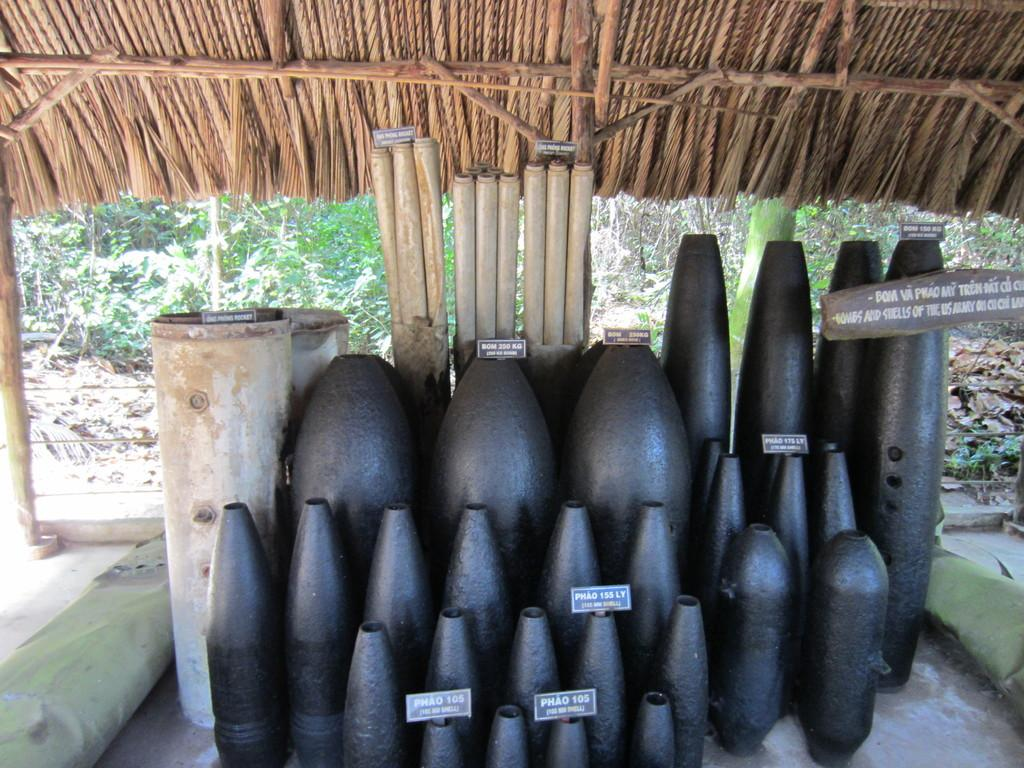What is the main subject of the image? The main subject of the image is ammunition. Can you describe the color of the ammunition? The ammunition is black in color. What can be seen in the background of the image? There are trees and the roof of a hut visible in the background of the image. Reasoning: Let'ing: Let's think step by step in order to produce the conversation. We start by identifying the main subject of the image, which is the ammunition. Next, we describe the color of the ammunition to provide more detail about its appearance. Finally, we mention the background elements, which include trees and the roof of a hut, to give a sense of the setting. Absurd Question/Answer: Can you see any writing on the ammunition in the image? There is no writing visible on the ammunition in the image. What type of cub is playing with the ammunition in the image? There is no cub present in the image, and the ammunition is not being played with. 